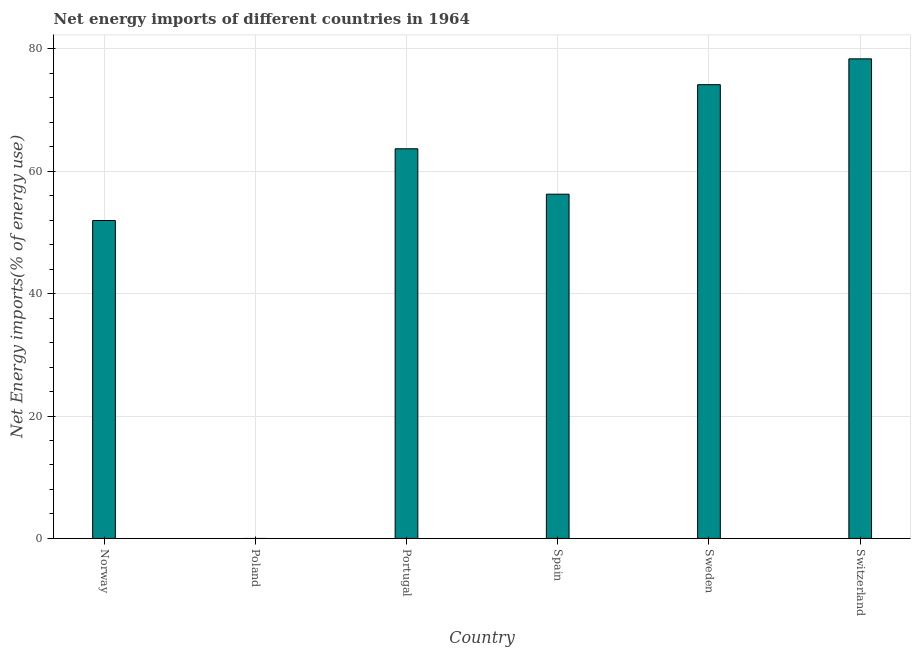What is the title of the graph?
Provide a short and direct response. Net energy imports of different countries in 1964. What is the label or title of the X-axis?
Ensure brevity in your answer.  Country. What is the label or title of the Y-axis?
Ensure brevity in your answer.  Net Energy imports(% of energy use). What is the energy imports in Norway?
Your response must be concise. 51.94. Across all countries, what is the maximum energy imports?
Provide a short and direct response. 78.34. In which country was the energy imports maximum?
Offer a very short reply. Switzerland. What is the sum of the energy imports?
Your answer should be compact. 324.29. What is the difference between the energy imports in Norway and Spain?
Give a very brief answer. -4.3. What is the average energy imports per country?
Provide a short and direct response. 54.05. What is the median energy imports?
Give a very brief answer. 59.94. In how many countries, is the energy imports greater than 60 %?
Offer a very short reply. 3. What is the ratio of the energy imports in Portugal to that in Sweden?
Make the answer very short. 0.86. Is the energy imports in Portugal less than that in Spain?
Your answer should be compact. No. Is the difference between the energy imports in Norway and Switzerland greater than the difference between any two countries?
Provide a short and direct response. No. What is the difference between the highest and the second highest energy imports?
Your answer should be compact. 4.22. Is the sum of the energy imports in Norway and Switzerland greater than the maximum energy imports across all countries?
Provide a short and direct response. Yes. What is the difference between the highest and the lowest energy imports?
Your answer should be very brief. 78.34. How many bars are there?
Your response must be concise. 5. How many countries are there in the graph?
Your answer should be compact. 6. Are the values on the major ticks of Y-axis written in scientific E-notation?
Provide a succinct answer. No. What is the Net Energy imports(% of energy use) of Norway?
Your answer should be very brief. 51.94. What is the Net Energy imports(% of energy use) in Poland?
Your response must be concise. 0. What is the Net Energy imports(% of energy use) in Portugal?
Give a very brief answer. 63.65. What is the Net Energy imports(% of energy use) of Spain?
Ensure brevity in your answer.  56.23. What is the Net Energy imports(% of energy use) in Sweden?
Give a very brief answer. 74.12. What is the Net Energy imports(% of energy use) in Switzerland?
Your response must be concise. 78.34. What is the difference between the Net Energy imports(% of energy use) in Norway and Portugal?
Your answer should be very brief. -11.71. What is the difference between the Net Energy imports(% of energy use) in Norway and Spain?
Give a very brief answer. -4.3. What is the difference between the Net Energy imports(% of energy use) in Norway and Sweden?
Offer a very short reply. -22.19. What is the difference between the Net Energy imports(% of energy use) in Norway and Switzerland?
Provide a short and direct response. -26.41. What is the difference between the Net Energy imports(% of energy use) in Portugal and Spain?
Keep it short and to the point. 7.42. What is the difference between the Net Energy imports(% of energy use) in Portugal and Sweden?
Ensure brevity in your answer.  -10.47. What is the difference between the Net Energy imports(% of energy use) in Portugal and Switzerland?
Make the answer very short. -14.69. What is the difference between the Net Energy imports(% of energy use) in Spain and Sweden?
Your answer should be very brief. -17.89. What is the difference between the Net Energy imports(% of energy use) in Spain and Switzerland?
Give a very brief answer. -22.11. What is the difference between the Net Energy imports(% of energy use) in Sweden and Switzerland?
Offer a very short reply. -4.22. What is the ratio of the Net Energy imports(% of energy use) in Norway to that in Portugal?
Make the answer very short. 0.82. What is the ratio of the Net Energy imports(% of energy use) in Norway to that in Spain?
Provide a short and direct response. 0.92. What is the ratio of the Net Energy imports(% of energy use) in Norway to that in Sweden?
Give a very brief answer. 0.7. What is the ratio of the Net Energy imports(% of energy use) in Norway to that in Switzerland?
Keep it short and to the point. 0.66. What is the ratio of the Net Energy imports(% of energy use) in Portugal to that in Spain?
Ensure brevity in your answer.  1.13. What is the ratio of the Net Energy imports(% of energy use) in Portugal to that in Sweden?
Your answer should be compact. 0.86. What is the ratio of the Net Energy imports(% of energy use) in Portugal to that in Switzerland?
Your response must be concise. 0.81. What is the ratio of the Net Energy imports(% of energy use) in Spain to that in Sweden?
Your response must be concise. 0.76. What is the ratio of the Net Energy imports(% of energy use) in Spain to that in Switzerland?
Give a very brief answer. 0.72. What is the ratio of the Net Energy imports(% of energy use) in Sweden to that in Switzerland?
Give a very brief answer. 0.95. 